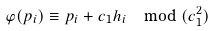<formula> <loc_0><loc_0><loc_500><loc_500>\varphi ( p _ { i } ) \equiv p _ { i } + c _ { 1 } h _ { i } \mod ( c _ { 1 } ^ { 2 } )</formula> 